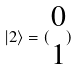<formula> <loc_0><loc_0><loc_500><loc_500>| 2 \rangle = ( \begin{matrix} 0 \\ 1 \end{matrix} )</formula> 